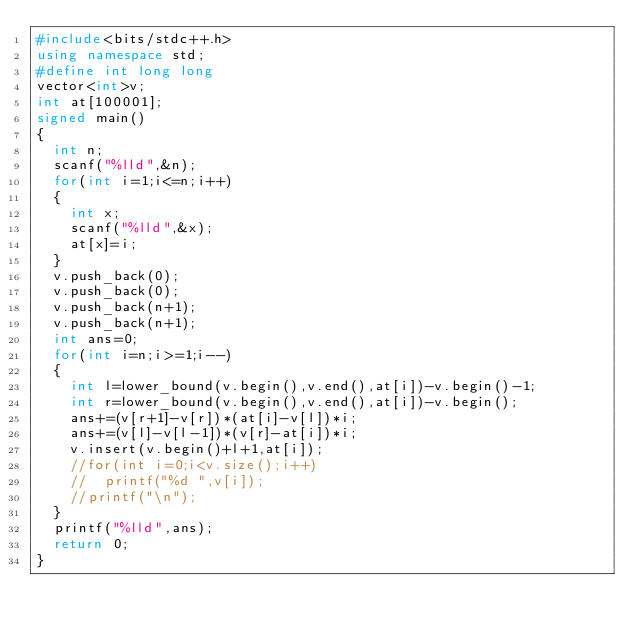Convert code to text. <code><loc_0><loc_0><loc_500><loc_500><_C++_>#include<bits/stdc++.h>
using namespace std;
#define int long long
vector<int>v;
int at[100001];
signed main()
{
	int n;
	scanf("%lld",&n);
	for(int i=1;i<=n;i++)
	{
		int x;
		scanf("%lld",&x);
		at[x]=i;
	}
	v.push_back(0);
	v.push_back(0);
	v.push_back(n+1);
	v.push_back(n+1);
	int ans=0;
	for(int i=n;i>=1;i--)
	{
		int l=lower_bound(v.begin(),v.end(),at[i])-v.begin()-1;
		int r=lower_bound(v.begin(),v.end(),at[i])-v.begin();
		ans+=(v[r+1]-v[r])*(at[i]-v[l])*i;
		ans+=(v[l]-v[l-1])*(v[r]-at[i])*i;
		v.insert(v.begin()+l+1,at[i]);
		//for(int i=0;i<v.size();i++)
		//	printf("%d ",v[i]);
		//printf("\n");
	}
	printf("%lld",ans);
	return 0;
}</code> 